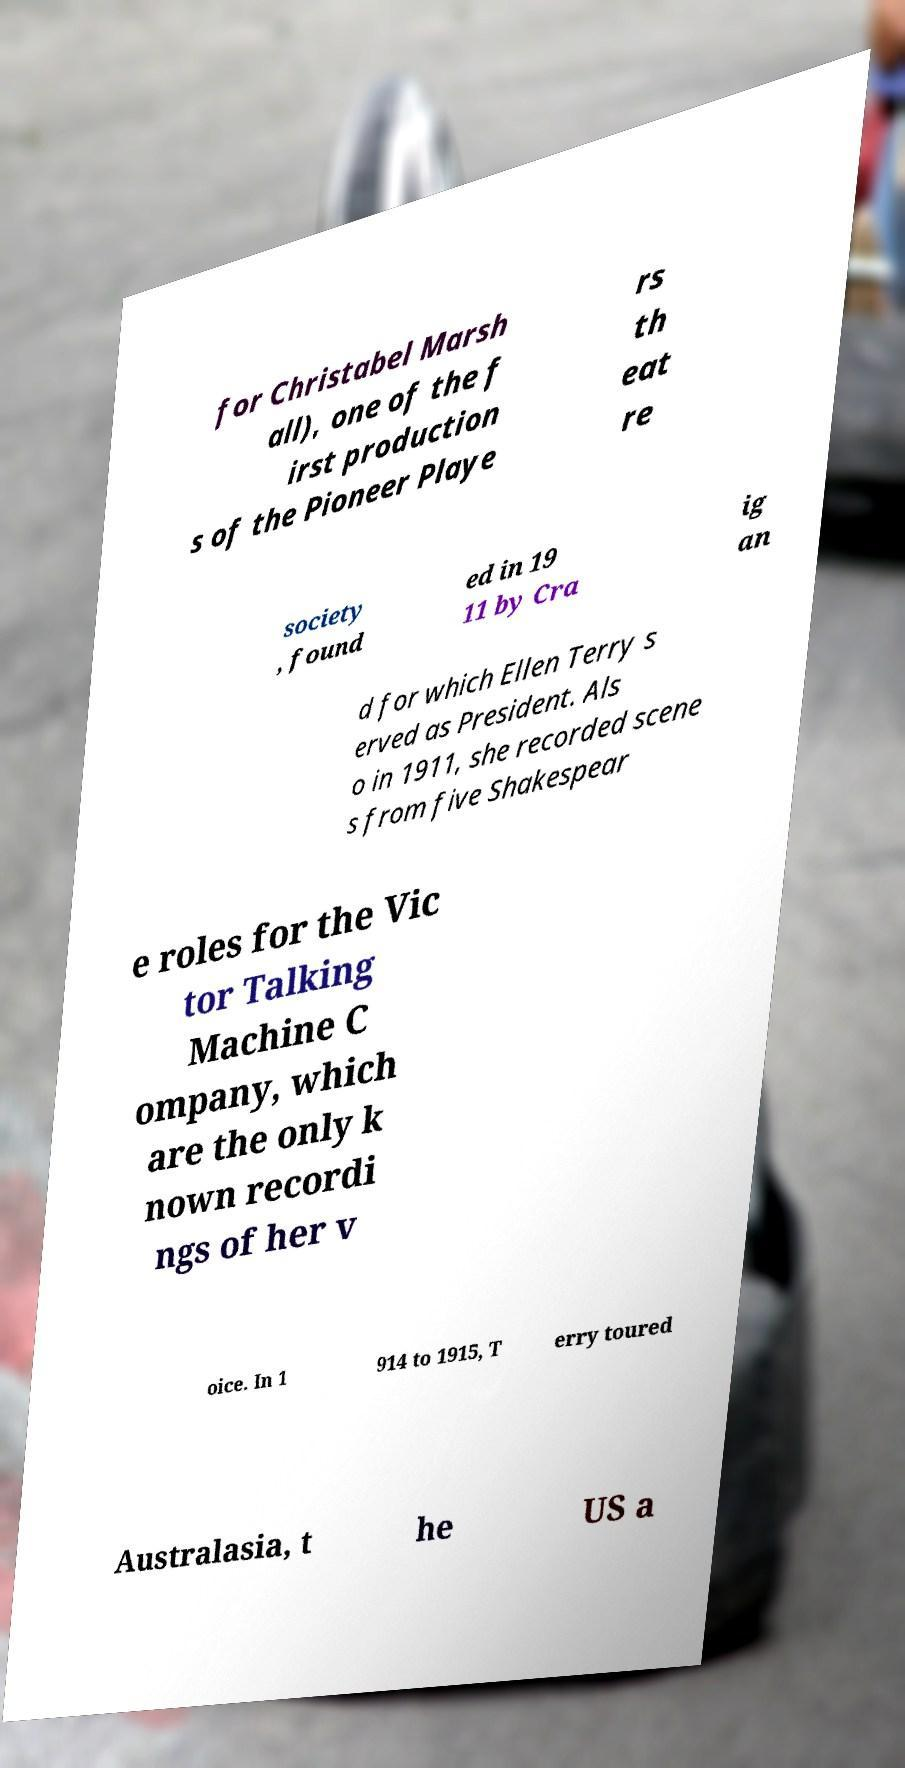Can you accurately transcribe the text from the provided image for me? for Christabel Marsh all), one of the f irst production s of the Pioneer Playe rs th eat re society , found ed in 19 11 by Cra ig an d for which Ellen Terry s erved as President. Als o in 1911, she recorded scene s from five Shakespear e roles for the Vic tor Talking Machine C ompany, which are the only k nown recordi ngs of her v oice. In 1 914 to 1915, T erry toured Australasia, t he US a 